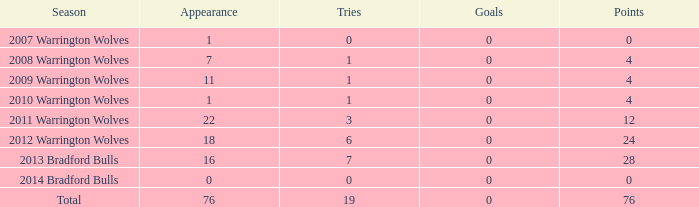What is the average tries for the season 2008 warrington wolves with an appearance more than 7? None. 